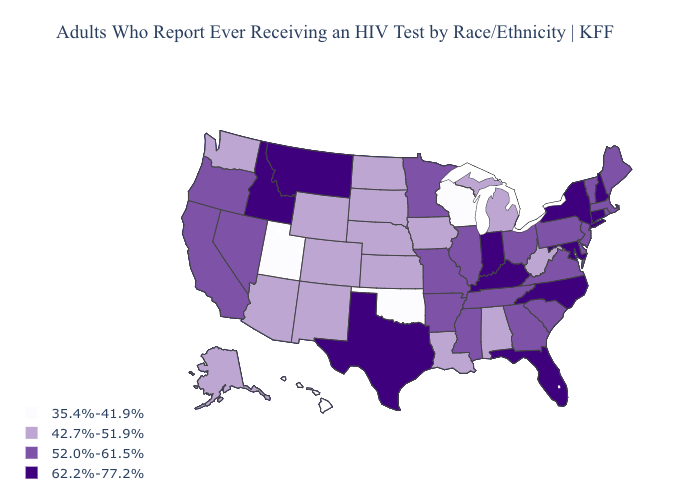Does Nevada have a higher value than Colorado?
Answer briefly. Yes. What is the value of Louisiana?
Be succinct. 42.7%-51.9%. What is the lowest value in states that border Florida?
Answer briefly. 42.7%-51.9%. Name the states that have a value in the range 42.7%-51.9%?
Concise answer only. Alabama, Alaska, Arizona, Colorado, Iowa, Kansas, Louisiana, Michigan, Nebraska, New Mexico, North Dakota, South Dakota, Washington, West Virginia, Wyoming. Name the states that have a value in the range 62.2%-77.2%?
Give a very brief answer. Connecticut, Florida, Idaho, Indiana, Kentucky, Maryland, Montana, New Hampshire, New York, North Carolina, Texas. Among the states that border Pennsylvania , does New Jersey have the lowest value?
Write a very short answer. No. What is the value of North Dakota?
Give a very brief answer. 42.7%-51.9%. What is the highest value in the USA?
Quick response, please. 62.2%-77.2%. Name the states that have a value in the range 52.0%-61.5%?
Quick response, please. Arkansas, California, Delaware, Georgia, Illinois, Maine, Massachusetts, Minnesota, Mississippi, Missouri, Nevada, New Jersey, Ohio, Oregon, Pennsylvania, Rhode Island, South Carolina, Tennessee, Vermont, Virginia. Name the states that have a value in the range 52.0%-61.5%?
Short answer required. Arkansas, California, Delaware, Georgia, Illinois, Maine, Massachusetts, Minnesota, Mississippi, Missouri, Nevada, New Jersey, Ohio, Oregon, Pennsylvania, Rhode Island, South Carolina, Tennessee, Vermont, Virginia. Does the map have missing data?
Write a very short answer. No. Does California have a higher value than North Carolina?
Quick response, please. No. Among the states that border Vermont , does Massachusetts have the lowest value?
Quick response, please. Yes. Does the first symbol in the legend represent the smallest category?
Answer briefly. Yes. 